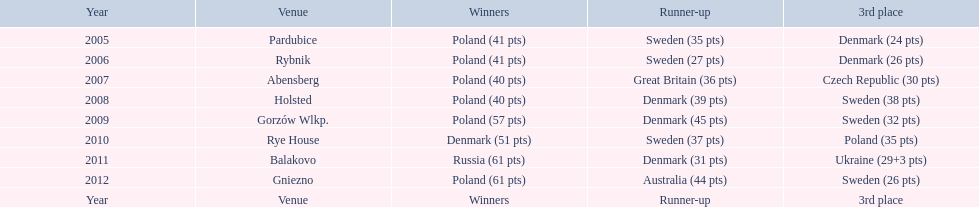What is the overall sum of points earned in the year 2009? 134. 